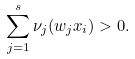Convert formula to latex. <formula><loc_0><loc_0><loc_500><loc_500>\sum _ { j = 1 } ^ { s } \nu _ { j } ( w _ { j } x _ { i } ) > 0 .</formula> 